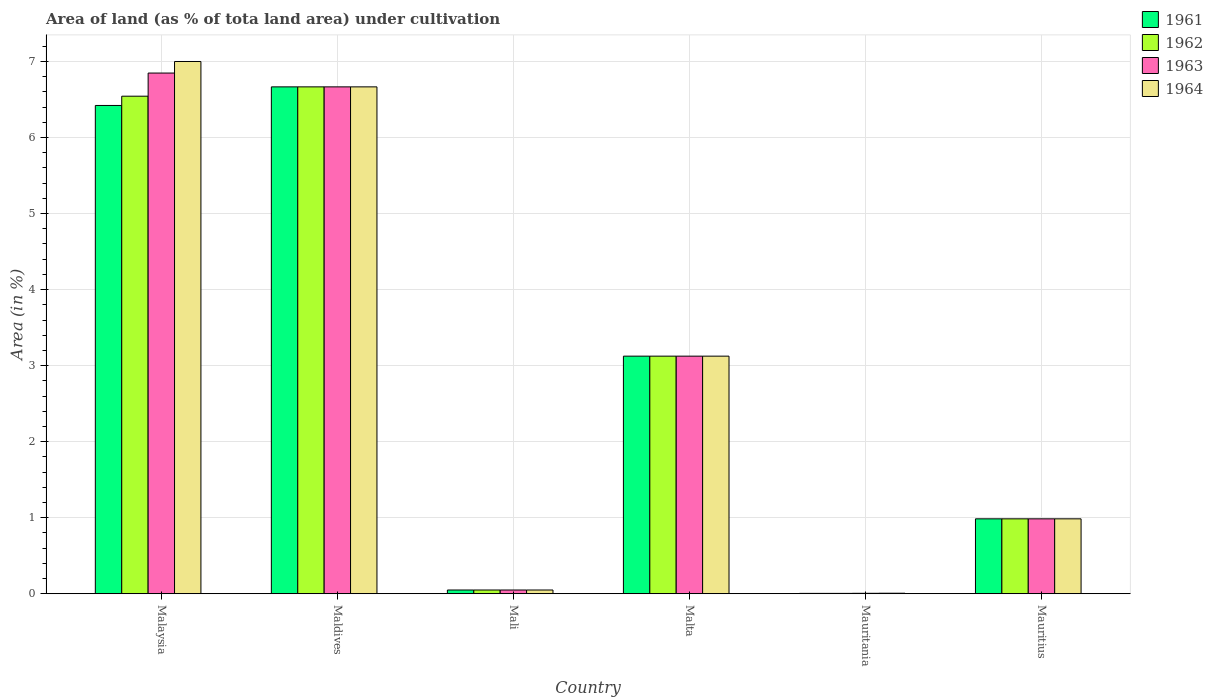How many groups of bars are there?
Your response must be concise. 6. How many bars are there on the 2nd tick from the right?
Your answer should be very brief. 4. What is the label of the 3rd group of bars from the left?
Keep it short and to the point. Mali. What is the percentage of land under cultivation in 1963 in Maldives?
Offer a very short reply. 6.67. Across all countries, what is the maximum percentage of land under cultivation in 1963?
Your answer should be very brief. 6.85. Across all countries, what is the minimum percentage of land under cultivation in 1963?
Your answer should be very brief. 0.01. In which country was the percentage of land under cultivation in 1964 maximum?
Your answer should be very brief. Malaysia. In which country was the percentage of land under cultivation in 1964 minimum?
Offer a terse response. Mauritania. What is the total percentage of land under cultivation in 1963 in the graph?
Give a very brief answer. 17.68. What is the difference between the percentage of land under cultivation in 1961 in Mauritania and that in Mauritius?
Offer a very short reply. -0.98. What is the difference between the percentage of land under cultivation in 1963 in Malaysia and the percentage of land under cultivation in 1961 in Maldives?
Your answer should be very brief. 0.18. What is the average percentage of land under cultivation in 1962 per country?
Ensure brevity in your answer.  2.9. In how many countries, is the percentage of land under cultivation in 1961 greater than 7 %?
Provide a succinct answer. 0. What is the ratio of the percentage of land under cultivation in 1964 in Malaysia to that in Maldives?
Offer a very short reply. 1.05. Is the difference between the percentage of land under cultivation in 1963 in Mali and Mauritania greater than the difference between the percentage of land under cultivation in 1961 in Mali and Mauritania?
Make the answer very short. No. What is the difference between the highest and the second highest percentage of land under cultivation in 1963?
Ensure brevity in your answer.  -3.72. What is the difference between the highest and the lowest percentage of land under cultivation in 1961?
Give a very brief answer. 6.66. In how many countries, is the percentage of land under cultivation in 1963 greater than the average percentage of land under cultivation in 1963 taken over all countries?
Your answer should be compact. 3. What does the 2nd bar from the left in Malaysia represents?
Ensure brevity in your answer.  1962. What does the 1st bar from the right in Malaysia represents?
Offer a very short reply. 1964. How many bars are there?
Offer a very short reply. 24. Are all the bars in the graph horizontal?
Ensure brevity in your answer.  No. How many countries are there in the graph?
Ensure brevity in your answer.  6. Are the values on the major ticks of Y-axis written in scientific E-notation?
Your answer should be very brief. No. Does the graph contain grids?
Make the answer very short. Yes. How many legend labels are there?
Your answer should be compact. 4. How are the legend labels stacked?
Provide a short and direct response. Vertical. What is the title of the graph?
Offer a terse response. Area of land (as % of tota land area) under cultivation. What is the label or title of the Y-axis?
Your response must be concise. Area (in %). What is the Area (in %) in 1961 in Malaysia?
Make the answer very short. 6.42. What is the Area (in %) of 1962 in Malaysia?
Offer a terse response. 6.54. What is the Area (in %) of 1963 in Malaysia?
Ensure brevity in your answer.  6.85. What is the Area (in %) of 1964 in Malaysia?
Your answer should be very brief. 7. What is the Area (in %) of 1961 in Maldives?
Keep it short and to the point. 6.67. What is the Area (in %) in 1962 in Maldives?
Your answer should be very brief. 6.67. What is the Area (in %) in 1963 in Maldives?
Provide a succinct answer. 6.67. What is the Area (in %) of 1964 in Maldives?
Keep it short and to the point. 6.67. What is the Area (in %) in 1961 in Mali?
Keep it short and to the point. 0.05. What is the Area (in %) in 1962 in Mali?
Your response must be concise. 0.05. What is the Area (in %) of 1963 in Mali?
Your answer should be very brief. 0.05. What is the Area (in %) in 1964 in Mali?
Ensure brevity in your answer.  0.05. What is the Area (in %) of 1961 in Malta?
Provide a short and direct response. 3.12. What is the Area (in %) in 1962 in Malta?
Keep it short and to the point. 3.12. What is the Area (in %) of 1963 in Malta?
Keep it short and to the point. 3.12. What is the Area (in %) in 1964 in Malta?
Provide a short and direct response. 3.12. What is the Area (in %) in 1961 in Mauritania?
Give a very brief answer. 0. What is the Area (in %) of 1962 in Mauritania?
Offer a terse response. 0. What is the Area (in %) of 1963 in Mauritania?
Offer a terse response. 0.01. What is the Area (in %) in 1964 in Mauritania?
Give a very brief answer. 0.01. What is the Area (in %) of 1961 in Mauritius?
Your answer should be compact. 0.99. What is the Area (in %) of 1962 in Mauritius?
Your response must be concise. 0.99. What is the Area (in %) in 1963 in Mauritius?
Ensure brevity in your answer.  0.99. What is the Area (in %) of 1964 in Mauritius?
Offer a very short reply. 0.99. Across all countries, what is the maximum Area (in %) in 1961?
Keep it short and to the point. 6.67. Across all countries, what is the maximum Area (in %) of 1962?
Provide a succinct answer. 6.67. Across all countries, what is the maximum Area (in %) of 1963?
Your answer should be very brief. 6.85. Across all countries, what is the maximum Area (in %) of 1964?
Your answer should be very brief. 7. Across all countries, what is the minimum Area (in %) of 1961?
Provide a short and direct response. 0. Across all countries, what is the minimum Area (in %) in 1962?
Give a very brief answer. 0. Across all countries, what is the minimum Area (in %) in 1963?
Make the answer very short. 0.01. Across all countries, what is the minimum Area (in %) in 1964?
Provide a short and direct response. 0.01. What is the total Area (in %) of 1961 in the graph?
Provide a succinct answer. 17.25. What is the total Area (in %) in 1962 in the graph?
Your answer should be compact. 17.37. What is the total Area (in %) in 1963 in the graph?
Make the answer very short. 17.68. What is the total Area (in %) of 1964 in the graph?
Offer a terse response. 17.83. What is the difference between the Area (in %) in 1961 in Malaysia and that in Maldives?
Your answer should be very brief. -0.24. What is the difference between the Area (in %) of 1962 in Malaysia and that in Maldives?
Offer a terse response. -0.12. What is the difference between the Area (in %) in 1963 in Malaysia and that in Maldives?
Offer a very short reply. 0.18. What is the difference between the Area (in %) of 1964 in Malaysia and that in Maldives?
Your answer should be compact. 0.33. What is the difference between the Area (in %) of 1961 in Malaysia and that in Mali?
Make the answer very short. 6.37. What is the difference between the Area (in %) in 1962 in Malaysia and that in Mali?
Offer a very short reply. 6.49. What is the difference between the Area (in %) in 1963 in Malaysia and that in Mali?
Ensure brevity in your answer.  6.8. What is the difference between the Area (in %) of 1964 in Malaysia and that in Mali?
Your answer should be compact. 6.95. What is the difference between the Area (in %) in 1961 in Malaysia and that in Malta?
Offer a very short reply. 3.3. What is the difference between the Area (in %) in 1962 in Malaysia and that in Malta?
Give a very brief answer. 3.42. What is the difference between the Area (in %) of 1963 in Malaysia and that in Malta?
Offer a very short reply. 3.72. What is the difference between the Area (in %) of 1964 in Malaysia and that in Malta?
Provide a short and direct response. 3.88. What is the difference between the Area (in %) of 1961 in Malaysia and that in Mauritania?
Offer a very short reply. 6.42. What is the difference between the Area (in %) of 1962 in Malaysia and that in Mauritania?
Offer a terse response. 6.54. What is the difference between the Area (in %) of 1963 in Malaysia and that in Mauritania?
Keep it short and to the point. 6.84. What is the difference between the Area (in %) of 1964 in Malaysia and that in Mauritania?
Keep it short and to the point. 6.99. What is the difference between the Area (in %) of 1961 in Malaysia and that in Mauritius?
Keep it short and to the point. 5.44. What is the difference between the Area (in %) in 1962 in Malaysia and that in Mauritius?
Provide a succinct answer. 5.56. What is the difference between the Area (in %) of 1963 in Malaysia and that in Mauritius?
Your answer should be very brief. 5.86. What is the difference between the Area (in %) of 1964 in Malaysia and that in Mauritius?
Ensure brevity in your answer.  6.02. What is the difference between the Area (in %) in 1961 in Maldives and that in Mali?
Provide a succinct answer. 6.62. What is the difference between the Area (in %) of 1962 in Maldives and that in Mali?
Provide a short and direct response. 6.62. What is the difference between the Area (in %) in 1963 in Maldives and that in Mali?
Your answer should be compact. 6.62. What is the difference between the Area (in %) of 1964 in Maldives and that in Mali?
Provide a short and direct response. 6.62. What is the difference between the Area (in %) of 1961 in Maldives and that in Malta?
Your answer should be compact. 3.54. What is the difference between the Area (in %) of 1962 in Maldives and that in Malta?
Give a very brief answer. 3.54. What is the difference between the Area (in %) in 1963 in Maldives and that in Malta?
Offer a very short reply. 3.54. What is the difference between the Area (in %) of 1964 in Maldives and that in Malta?
Offer a very short reply. 3.54. What is the difference between the Area (in %) in 1961 in Maldives and that in Mauritania?
Keep it short and to the point. 6.66. What is the difference between the Area (in %) of 1962 in Maldives and that in Mauritania?
Offer a very short reply. 6.66. What is the difference between the Area (in %) of 1963 in Maldives and that in Mauritania?
Provide a succinct answer. 6.66. What is the difference between the Area (in %) of 1964 in Maldives and that in Mauritania?
Provide a succinct answer. 6.66. What is the difference between the Area (in %) in 1961 in Maldives and that in Mauritius?
Offer a terse response. 5.68. What is the difference between the Area (in %) in 1962 in Maldives and that in Mauritius?
Your answer should be compact. 5.68. What is the difference between the Area (in %) of 1963 in Maldives and that in Mauritius?
Your answer should be compact. 5.68. What is the difference between the Area (in %) in 1964 in Maldives and that in Mauritius?
Your response must be concise. 5.68. What is the difference between the Area (in %) of 1961 in Mali and that in Malta?
Provide a short and direct response. -3.08. What is the difference between the Area (in %) of 1962 in Mali and that in Malta?
Make the answer very short. -3.08. What is the difference between the Area (in %) in 1963 in Mali and that in Malta?
Your answer should be compact. -3.08. What is the difference between the Area (in %) in 1964 in Mali and that in Malta?
Keep it short and to the point. -3.08. What is the difference between the Area (in %) in 1961 in Mali and that in Mauritania?
Keep it short and to the point. 0.04. What is the difference between the Area (in %) in 1962 in Mali and that in Mauritania?
Your answer should be compact. 0.04. What is the difference between the Area (in %) of 1963 in Mali and that in Mauritania?
Keep it short and to the point. 0.04. What is the difference between the Area (in %) of 1964 in Mali and that in Mauritania?
Give a very brief answer. 0.04. What is the difference between the Area (in %) of 1961 in Mali and that in Mauritius?
Make the answer very short. -0.94. What is the difference between the Area (in %) of 1962 in Mali and that in Mauritius?
Your answer should be compact. -0.94. What is the difference between the Area (in %) of 1963 in Mali and that in Mauritius?
Provide a short and direct response. -0.94. What is the difference between the Area (in %) in 1964 in Mali and that in Mauritius?
Your answer should be compact. -0.94. What is the difference between the Area (in %) of 1961 in Malta and that in Mauritania?
Provide a short and direct response. 3.12. What is the difference between the Area (in %) in 1962 in Malta and that in Mauritania?
Make the answer very short. 3.12. What is the difference between the Area (in %) in 1963 in Malta and that in Mauritania?
Provide a short and direct response. 3.12. What is the difference between the Area (in %) in 1964 in Malta and that in Mauritania?
Offer a very short reply. 3.12. What is the difference between the Area (in %) in 1961 in Malta and that in Mauritius?
Ensure brevity in your answer.  2.14. What is the difference between the Area (in %) in 1962 in Malta and that in Mauritius?
Ensure brevity in your answer.  2.14. What is the difference between the Area (in %) of 1963 in Malta and that in Mauritius?
Your response must be concise. 2.14. What is the difference between the Area (in %) in 1964 in Malta and that in Mauritius?
Provide a short and direct response. 2.14. What is the difference between the Area (in %) of 1961 in Mauritania and that in Mauritius?
Offer a terse response. -0.98. What is the difference between the Area (in %) in 1962 in Mauritania and that in Mauritius?
Your response must be concise. -0.98. What is the difference between the Area (in %) in 1963 in Mauritania and that in Mauritius?
Keep it short and to the point. -0.98. What is the difference between the Area (in %) in 1964 in Mauritania and that in Mauritius?
Offer a terse response. -0.98. What is the difference between the Area (in %) of 1961 in Malaysia and the Area (in %) of 1962 in Maldives?
Provide a short and direct response. -0.24. What is the difference between the Area (in %) of 1961 in Malaysia and the Area (in %) of 1963 in Maldives?
Provide a short and direct response. -0.24. What is the difference between the Area (in %) of 1961 in Malaysia and the Area (in %) of 1964 in Maldives?
Provide a succinct answer. -0.24. What is the difference between the Area (in %) of 1962 in Malaysia and the Area (in %) of 1963 in Maldives?
Offer a terse response. -0.12. What is the difference between the Area (in %) of 1962 in Malaysia and the Area (in %) of 1964 in Maldives?
Your answer should be compact. -0.12. What is the difference between the Area (in %) in 1963 in Malaysia and the Area (in %) in 1964 in Maldives?
Ensure brevity in your answer.  0.18. What is the difference between the Area (in %) of 1961 in Malaysia and the Area (in %) of 1962 in Mali?
Your response must be concise. 6.37. What is the difference between the Area (in %) in 1961 in Malaysia and the Area (in %) in 1963 in Mali?
Ensure brevity in your answer.  6.37. What is the difference between the Area (in %) in 1961 in Malaysia and the Area (in %) in 1964 in Mali?
Your answer should be very brief. 6.37. What is the difference between the Area (in %) in 1962 in Malaysia and the Area (in %) in 1963 in Mali?
Provide a succinct answer. 6.49. What is the difference between the Area (in %) of 1962 in Malaysia and the Area (in %) of 1964 in Mali?
Give a very brief answer. 6.49. What is the difference between the Area (in %) in 1963 in Malaysia and the Area (in %) in 1964 in Mali?
Provide a succinct answer. 6.8. What is the difference between the Area (in %) in 1961 in Malaysia and the Area (in %) in 1962 in Malta?
Your response must be concise. 3.3. What is the difference between the Area (in %) in 1961 in Malaysia and the Area (in %) in 1963 in Malta?
Give a very brief answer. 3.3. What is the difference between the Area (in %) of 1961 in Malaysia and the Area (in %) of 1964 in Malta?
Offer a terse response. 3.3. What is the difference between the Area (in %) in 1962 in Malaysia and the Area (in %) in 1963 in Malta?
Provide a short and direct response. 3.42. What is the difference between the Area (in %) of 1962 in Malaysia and the Area (in %) of 1964 in Malta?
Keep it short and to the point. 3.42. What is the difference between the Area (in %) of 1963 in Malaysia and the Area (in %) of 1964 in Malta?
Your answer should be very brief. 3.72. What is the difference between the Area (in %) in 1961 in Malaysia and the Area (in %) in 1962 in Mauritania?
Your answer should be compact. 6.42. What is the difference between the Area (in %) of 1961 in Malaysia and the Area (in %) of 1963 in Mauritania?
Provide a short and direct response. 6.42. What is the difference between the Area (in %) in 1961 in Malaysia and the Area (in %) in 1964 in Mauritania?
Your answer should be very brief. 6.42. What is the difference between the Area (in %) of 1962 in Malaysia and the Area (in %) of 1963 in Mauritania?
Offer a terse response. 6.54. What is the difference between the Area (in %) in 1962 in Malaysia and the Area (in %) in 1964 in Mauritania?
Your answer should be very brief. 6.54. What is the difference between the Area (in %) of 1963 in Malaysia and the Area (in %) of 1964 in Mauritania?
Your answer should be very brief. 6.84. What is the difference between the Area (in %) in 1961 in Malaysia and the Area (in %) in 1962 in Mauritius?
Give a very brief answer. 5.44. What is the difference between the Area (in %) of 1961 in Malaysia and the Area (in %) of 1963 in Mauritius?
Your answer should be compact. 5.44. What is the difference between the Area (in %) of 1961 in Malaysia and the Area (in %) of 1964 in Mauritius?
Offer a very short reply. 5.44. What is the difference between the Area (in %) in 1962 in Malaysia and the Area (in %) in 1963 in Mauritius?
Ensure brevity in your answer.  5.56. What is the difference between the Area (in %) of 1962 in Malaysia and the Area (in %) of 1964 in Mauritius?
Offer a very short reply. 5.56. What is the difference between the Area (in %) in 1963 in Malaysia and the Area (in %) in 1964 in Mauritius?
Provide a short and direct response. 5.86. What is the difference between the Area (in %) in 1961 in Maldives and the Area (in %) in 1962 in Mali?
Offer a very short reply. 6.62. What is the difference between the Area (in %) in 1961 in Maldives and the Area (in %) in 1963 in Mali?
Offer a very short reply. 6.62. What is the difference between the Area (in %) of 1961 in Maldives and the Area (in %) of 1964 in Mali?
Give a very brief answer. 6.62. What is the difference between the Area (in %) of 1962 in Maldives and the Area (in %) of 1963 in Mali?
Offer a very short reply. 6.62. What is the difference between the Area (in %) of 1962 in Maldives and the Area (in %) of 1964 in Mali?
Provide a short and direct response. 6.62. What is the difference between the Area (in %) in 1963 in Maldives and the Area (in %) in 1964 in Mali?
Make the answer very short. 6.62. What is the difference between the Area (in %) of 1961 in Maldives and the Area (in %) of 1962 in Malta?
Offer a very short reply. 3.54. What is the difference between the Area (in %) in 1961 in Maldives and the Area (in %) in 1963 in Malta?
Your answer should be compact. 3.54. What is the difference between the Area (in %) of 1961 in Maldives and the Area (in %) of 1964 in Malta?
Ensure brevity in your answer.  3.54. What is the difference between the Area (in %) of 1962 in Maldives and the Area (in %) of 1963 in Malta?
Your response must be concise. 3.54. What is the difference between the Area (in %) in 1962 in Maldives and the Area (in %) in 1964 in Malta?
Offer a terse response. 3.54. What is the difference between the Area (in %) in 1963 in Maldives and the Area (in %) in 1964 in Malta?
Offer a terse response. 3.54. What is the difference between the Area (in %) in 1961 in Maldives and the Area (in %) in 1962 in Mauritania?
Offer a terse response. 6.66. What is the difference between the Area (in %) in 1961 in Maldives and the Area (in %) in 1963 in Mauritania?
Offer a terse response. 6.66. What is the difference between the Area (in %) in 1961 in Maldives and the Area (in %) in 1964 in Mauritania?
Ensure brevity in your answer.  6.66. What is the difference between the Area (in %) in 1962 in Maldives and the Area (in %) in 1963 in Mauritania?
Provide a short and direct response. 6.66. What is the difference between the Area (in %) in 1962 in Maldives and the Area (in %) in 1964 in Mauritania?
Keep it short and to the point. 6.66. What is the difference between the Area (in %) in 1963 in Maldives and the Area (in %) in 1964 in Mauritania?
Offer a very short reply. 6.66. What is the difference between the Area (in %) in 1961 in Maldives and the Area (in %) in 1962 in Mauritius?
Offer a very short reply. 5.68. What is the difference between the Area (in %) of 1961 in Maldives and the Area (in %) of 1963 in Mauritius?
Give a very brief answer. 5.68. What is the difference between the Area (in %) in 1961 in Maldives and the Area (in %) in 1964 in Mauritius?
Keep it short and to the point. 5.68. What is the difference between the Area (in %) in 1962 in Maldives and the Area (in %) in 1963 in Mauritius?
Offer a terse response. 5.68. What is the difference between the Area (in %) in 1962 in Maldives and the Area (in %) in 1964 in Mauritius?
Provide a succinct answer. 5.68. What is the difference between the Area (in %) in 1963 in Maldives and the Area (in %) in 1964 in Mauritius?
Provide a short and direct response. 5.68. What is the difference between the Area (in %) in 1961 in Mali and the Area (in %) in 1962 in Malta?
Give a very brief answer. -3.08. What is the difference between the Area (in %) of 1961 in Mali and the Area (in %) of 1963 in Malta?
Offer a terse response. -3.08. What is the difference between the Area (in %) in 1961 in Mali and the Area (in %) in 1964 in Malta?
Your answer should be very brief. -3.08. What is the difference between the Area (in %) in 1962 in Mali and the Area (in %) in 1963 in Malta?
Give a very brief answer. -3.08. What is the difference between the Area (in %) of 1962 in Mali and the Area (in %) of 1964 in Malta?
Provide a short and direct response. -3.08. What is the difference between the Area (in %) of 1963 in Mali and the Area (in %) of 1964 in Malta?
Your response must be concise. -3.08. What is the difference between the Area (in %) of 1961 in Mali and the Area (in %) of 1962 in Mauritania?
Your answer should be compact. 0.04. What is the difference between the Area (in %) in 1961 in Mali and the Area (in %) in 1963 in Mauritania?
Make the answer very short. 0.04. What is the difference between the Area (in %) of 1961 in Mali and the Area (in %) of 1964 in Mauritania?
Your answer should be very brief. 0.04. What is the difference between the Area (in %) of 1962 in Mali and the Area (in %) of 1963 in Mauritania?
Offer a very short reply. 0.04. What is the difference between the Area (in %) of 1962 in Mali and the Area (in %) of 1964 in Mauritania?
Provide a succinct answer. 0.04. What is the difference between the Area (in %) in 1963 in Mali and the Area (in %) in 1964 in Mauritania?
Give a very brief answer. 0.04. What is the difference between the Area (in %) in 1961 in Mali and the Area (in %) in 1962 in Mauritius?
Offer a terse response. -0.94. What is the difference between the Area (in %) in 1961 in Mali and the Area (in %) in 1963 in Mauritius?
Give a very brief answer. -0.94. What is the difference between the Area (in %) of 1961 in Mali and the Area (in %) of 1964 in Mauritius?
Keep it short and to the point. -0.94. What is the difference between the Area (in %) of 1962 in Mali and the Area (in %) of 1963 in Mauritius?
Keep it short and to the point. -0.94. What is the difference between the Area (in %) in 1962 in Mali and the Area (in %) in 1964 in Mauritius?
Make the answer very short. -0.94. What is the difference between the Area (in %) of 1963 in Mali and the Area (in %) of 1964 in Mauritius?
Give a very brief answer. -0.94. What is the difference between the Area (in %) of 1961 in Malta and the Area (in %) of 1962 in Mauritania?
Ensure brevity in your answer.  3.12. What is the difference between the Area (in %) in 1961 in Malta and the Area (in %) in 1963 in Mauritania?
Give a very brief answer. 3.12. What is the difference between the Area (in %) in 1961 in Malta and the Area (in %) in 1964 in Mauritania?
Offer a very short reply. 3.12. What is the difference between the Area (in %) of 1962 in Malta and the Area (in %) of 1963 in Mauritania?
Keep it short and to the point. 3.12. What is the difference between the Area (in %) of 1962 in Malta and the Area (in %) of 1964 in Mauritania?
Make the answer very short. 3.12. What is the difference between the Area (in %) of 1963 in Malta and the Area (in %) of 1964 in Mauritania?
Give a very brief answer. 3.12. What is the difference between the Area (in %) in 1961 in Malta and the Area (in %) in 1962 in Mauritius?
Keep it short and to the point. 2.14. What is the difference between the Area (in %) of 1961 in Malta and the Area (in %) of 1963 in Mauritius?
Your response must be concise. 2.14. What is the difference between the Area (in %) of 1961 in Malta and the Area (in %) of 1964 in Mauritius?
Ensure brevity in your answer.  2.14. What is the difference between the Area (in %) in 1962 in Malta and the Area (in %) in 1963 in Mauritius?
Provide a short and direct response. 2.14. What is the difference between the Area (in %) in 1962 in Malta and the Area (in %) in 1964 in Mauritius?
Offer a terse response. 2.14. What is the difference between the Area (in %) in 1963 in Malta and the Area (in %) in 1964 in Mauritius?
Offer a terse response. 2.14. What is the difference between the Area (in %) of 1961 in Mauritania and the Area (in %) of 1962 in Mauritius?
Offer a terse response. -0.98. What is the difference between the Area (in %) of 1961 in Mauritania and the Area (in %) of 1963 in Mauritius?
Your answer should be compact. -0.98. What is the difference between the Area (in %) in 1961 in Mauritania and the Area (in %) in 1964 in Mauritius?
Offer a very short reply. -0.98. What is the difference between the Area (in %) in 1962 in Mauritania and the Area (in %) in 1963 in Mauritius?
Your answer should be compact. -0.98. What is the difference between the Area (in %) in 1962 in Mauritania and the Area (in %) in 1964 in Mauritius?
Offer a very short reply. -0.98. What is the difference between the Area (in %) in 1963 in Mauritania and the Area (in %) in 1964 in Mauritius?
Your answer should be very brief. -0.98. What is the average Area (in %) in 1961 per country?
Offer a terse response. 2.88. What is the average Area (in %) of 1962 per country?
Your response must be concise. 2.9. What is the average Area (in %) in 1963 per country?
Keep it short and to the point. 2.95. What is the average Area (in %) of 1964 per country?
Make the answer very short. 2.97. What is the difference between the Area (in %) in 1961 and Area (in %) in 1962 in Malaysia?
Your answer should be compact. -0.12. What is the difference between the Area (in %) of 1961 and Area (in %) of 1963 in Malaysia?
Your answer should be compact. -0.43. What is the difference between the Area (in %) of 1961 and Area (in %) of 1964 in Malaysia?
Make the answer very short. -0.58. What is the difference between the Area (in %) in 1962 and Area (in %) in 1963 in Malaysia?
Your answer should be compact. -0.3. What is the difference between the Area (in %) of 1962 and Area (in %) of 1964 in Malaysia?
Ensure brevity in your answer.  -0.46. What is the difference between the Area (in %) of 1963 and Area (in %) of 1964 in Malaysia?
Give a very brief answer. -0.15. What is the difference between the Area (in %) in 1961 and Area (in %) in 1962 in Maldives?
Keep it short and to the point. 0. What is the difference between the Area (in %) in 1961 and Area (in %) in 1963 in Maldives?
Ensure brevity in your answer.  0. What is the difference between the Area (in %) of 1961 and Area (in %) of 1964 in Maldives?
Keep it short and to the point. 0. What is the difference between the Area (in %) of 1962 and Area (in %) of 1964 in Maldives?
Offer a terse response. 0. What is the difference between the Area (in %) of 1963 and Area (in %) of 1964 in Maldives?
Your answer should be compact. 0. What is the difference between the Area (in %) of 1961 and Area (in %) of 1963 in Mali?
Ensure brevity in your answer.  0. What is the difference between the Area (in %) in 1962 and Area (in %) in 1963 in Mali?
Make the answer very short. 0. What is the difference between the Area (in %) of 1962 and Area (in %) of 1964 in Mali?
Ensure brevity in your answer.  0. What is the difference between the Area (in %) in 1961 and Area (in %) in 1963 in Malta?
Offer a terse response. 0. What is the difference between the Area (in %) of 1962 and Area (in %) of 1963 in Malta?
Give a very brief answer. 0. What is the difference between the Area (in %) in 1962 and Area (in %) in 1964 in Malta?
Make the answer very short. 0. What is the difference between the Area (in %) of 1961 and Area (in %) of 1963 in Mauritania?
Provide a short and direct response. -0. What is the difference between the Area (in %) of 1961 and Area (in %) of 1964 in Mauritania?
Make the answer very short. -0. What is the difference between the Area (in %) in 1962 and Area (in %) in 1963 in Mauritania?
Your answer should be compact. -0. What is the difference between the Area (in %) in 1962 and Area (in %) in 1964 in Mauritania?
Keep it short and to the point. -0. What is the difference between the Area (in %) of 1963 and Area (in %) of 1964 in Mauritania?
Your response must be concise. -0. What is the difference between the Area (in %) in 1962 and Area (in %) in 1963 in Mauritius?
Ensure brevity in your answer.  0. What is the difference between the Area (in %) in 1962 and Area (in %) in 1964 in Mauritius?
Offer a terse response. 0. What is the ratio of the Area (in %) in 1961 in Malaysia to that in Maldives?
Give a very brief answer. 0.96. What is the ratio of the Area (in %) in 1962 in Malaysia to that in Maldives?
Make the answer very short. 0.98. What is the ratio of the Area (in %) of 1963 in Malaysia to that in Maldives?
Provide a succinct answer. 1.03. What is the ratio of the Area (in %) of 1964 in Malaysia to that in Maldives?
Make the answer very short. 1.05. What is the ratio of the Area (in %) of 1961 in Malaysia to that in Mali?
Make the answer very short. 130.6. What is the ratio of the Area (in %) of 1962 in Malaysia to that in Mali?
Your answer should be very brief. 133.08. What is the ratio of the Area (in %) of 1963 in Malaysia to that in Mali?
Provide a succinct answer. 139.27. What is the ratio of the Area (in %) of 1964 in Malaysia to that in Mali?
Ensure brevity in your answer.  142.36. What is the ratio of the Area (in %) in 1961 in Malaysia to that in Malta?
Keep it short and to the point. 2.06. What is the ratio of the Area (in %) of 1962 in Malaysia to that in Malta?
Your answer should be compact. 2.09. What is the ratio of the Area (in %) of 1963 in Malaysia to that in Malta?
Your answer should be very brief. 2.19. What is the ratio of the Area (in %) in 1964 in Malaysia to that in Malta?
Keep it short and to the point. 2.24. What is the ratio of the Area (in %) in 1961 in Malaysia to that in Mauritania?
Give a very brief answer. 1323.86. What is the ratio of the Area (in %) in 1962 in Malaysia to that in Mauritania?
Provide a succinct answer. 1348.96. What is the ratio of the Area (in %) in 1963 in Malaysia to that in Mauritania?
Provide a succinct answer. 1176.42. What is the ratio of the Area (in %) in 1964 in Malaysia to that in Mauritania?
Keep it short and to the point. 1030.77. What is the ratio of the Area (in %) in 1961 in Malaysia to that in Mauritius?
Ensure brevity in your answer.  6.52. What is the ratio of the Area (in %) in 1962 in Malaysia to that in Mauritius?
Provide a succinct answer. 6.64. What is the ratio of the Area (in %) in 1963 in Malaysia to that in Mauritius?
Make the answer very short. 6.95. What is the ratio of the Area (in %) of 1964 in Malaysia to that in Mauritius?
Give a very brief answer. 7.11. What is the ratio of the Area (in %) in 1961 in Maldives to that in Mali?
Your answer should be compact. 135.58. What is the ratio of the Area (in %) in 1962 in Maldives to that in Mali?
Ensure brevity in your answer.  135.58. What is the ratio of the Area (in %) in 1963 in Maldives to that in Mali?
Ensure brevity in your answer.  135.58. What is the ratio of the Area (in %) in 1964 in Maldives to that in Mali?
Keep it short and to the point. 135.58. What is the ratio of the Area (in %) of 1961 in Maldives to that in Malta?
Offer a terse response. 2.13. What is the ratio of the Area (in %) in 1962 in Maldives to that in Malta?
Offer a very short reply. 2.13. What is the ratio of the Area (in %) of 1963 in Maldives to that in Malta?
Provide a succinct answer. 2.13. What is the ratio of the Area (in %) in 1964 in Maldives to that in Malta?
Offer a terse response. 2.13. What is the ratio of the Area (in %) of 1961 in Maldives to that in Mauritania?
Ensure brevity in your answer.  1374.27. What is the ratio of the Area (in %) of 1962 in Maldives to that in Mauritania?
Offer a terse response. 1374.27. What is the ratio of the Area (in %) of 1963 in Maldives to that in Mauritania?
Your answer should be compact. 1145.22. What is the ratio of the Area (in %) of 1964 in Maldives to that in Mauritania?
Provide a short and direct response. 981.62. What is the ratio of the Area (in %) of 1961 in Maldives to that in Mauritius?
Give a very brief answer. 6.77. What is the ratio of the Area (in %) of 1962 in Maldives to that in Mauritius?
Offer a terse response. 6.77. What is the ratio of the Area (in %) in 1963 in Maldives to that in Mauritius?
Give a very brief answer. 6.77. What is the ratio of the Area (in %) of 1964 in Maldives to that in Mauritius?
Your answer should be compact. 6.77. What is the ratio of the Area (in %) in 1961 in Mali to that in Malta?
Your answer should be very brief. 0.02. What is the ratio of the Area (in %) of 1962 in Mali to that in Malta?
Offer a terse response. 0.02. What is the ratio of the Area (in %) of 1963 in Mali to that in Malta?
Your answer should be compact. 0.02. What is the ratio of the Area (in %) in 1964 in Mali to that in Malta?
Give a very brief answer. 0.02. What is the ratio of the Area (in %) of 1961 in Mali to that in Mauritania?
Offer a terse response. 10.14. What is the ratio of the Area (in %) of 1962 in Mali to that in Mauritania?
Your response must be concise. 10.14. What is the ratio of the Area (in %) of 1963 in Mali to that in Mauritania?
Your answer should be compact. 8.45. What is the ratio of the Area (in %) in 1964 in Mali to that in Mauritania?
Ensure brevity in your answer.  7.24. What is the ratio of the Area (in %) of 1961 in Mali to that in Mauritius?
Your answer should be very brief. 0.05. What is the ratio of the Area (in %) of 1962 in Mali to that in Mauritius?
Provide a short and direct response. 0.05. What is the ratio of the Area (in %) of 1963 in Mali to that in Mauritius?
Provide a short and direct response. 0.05. What is the ratio of the Area (in %) in 1964 in Mali to that in Mauritius?
Your answer should be compact. 0.05. What is the ratio of the Area (in %) of 1961 in Malta to that in Mauritania?
Provide a short and direct response. 644.19. What is the ratio of the Area (in %) in 1962 in Malta to that in Mauritania?
Provide a succinct answer. 644.19. What is the ratio of the Area (in %) of 1963 in Malta to that in Mauritania?
Provide a short and direct response. 536.82. What is the ratio of the Area (in %) of 1964 in Malta to that in Mauritania?
Provide a succinct answer. 460.13. What is the ratio of the Area (in %) of 1961 in Malta to that in Mauritius?
Your answer should be compact. 3.17. What is the ratio of the Area (in %) of 1962 in Malta to that in Mauritius?
Your response must be concise. 3.17. What is the ratio of the Area (in %) of 1963 in Malta to that in Mauritius?
Offer a very short reply. 3.17. What is the ratio of the Area (in %) in 1964 in Malta to that in Mauritius?
Provide a succinct answer. 3.17. What is the ratio of the Area (in %) in 1961 in Mauritania to that in Mauritius?
Make the answer very short. 0. What is the ratio of the Area (in %) in 1962 in Mauritania to that in Mauritius?
Your response must be concise. 0. What is the ratio of the Area (in %) of 1963 in Mauritania to that in Mauritius?
Ensure brevity in your answer.  0.01. What is the ratio of the Area (in %) in 1964 in Mauritania to that in Mauritius?
Provide a succinct answer. 0.01. What is the difference between the highest and the second highest Area (in %) of 1961?
Your answer should be compact. 0.24. What is the difference between the highest and the second highest Area (in %) of 1962?
Your response must be concise. 0.12. What is the difference between the highest and the second highest Area (in %) of 1963?
Provide a succinct answer. 0.18. What is the difference between the highest and the second highest Area (in %) of 1964?
Ensure brevity in your answer.  0.33. What is the difference between the highest and the lowest Area (in %) of 1961?
Make the answer very short. 6.66. What is the difference between the highest and the lowest Area (in %) of 1962?
Offer a very short reply. 6.66. What is the difference between the highest and the lowest Area (in %) in 1963?
Provide a succinct answer. 6.84. What is the difference between the highest and the lowest Area (in %) in 1964?
Your response must be concise. 6.99. 